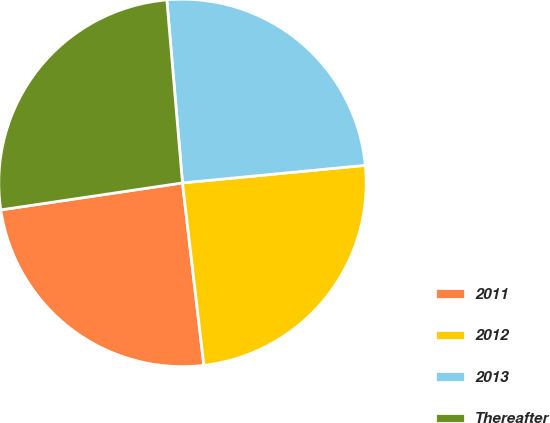<chart> <loc_0><loc_0><loc_500><loc_500><pie_chart><fcel>2011<fcel>2012<fcel>2013<fcel>Thereafter<nl><fcel>24.51%<fcel>24.67%<fcel>24.83%<fcel>25.99%<nl></chart> 